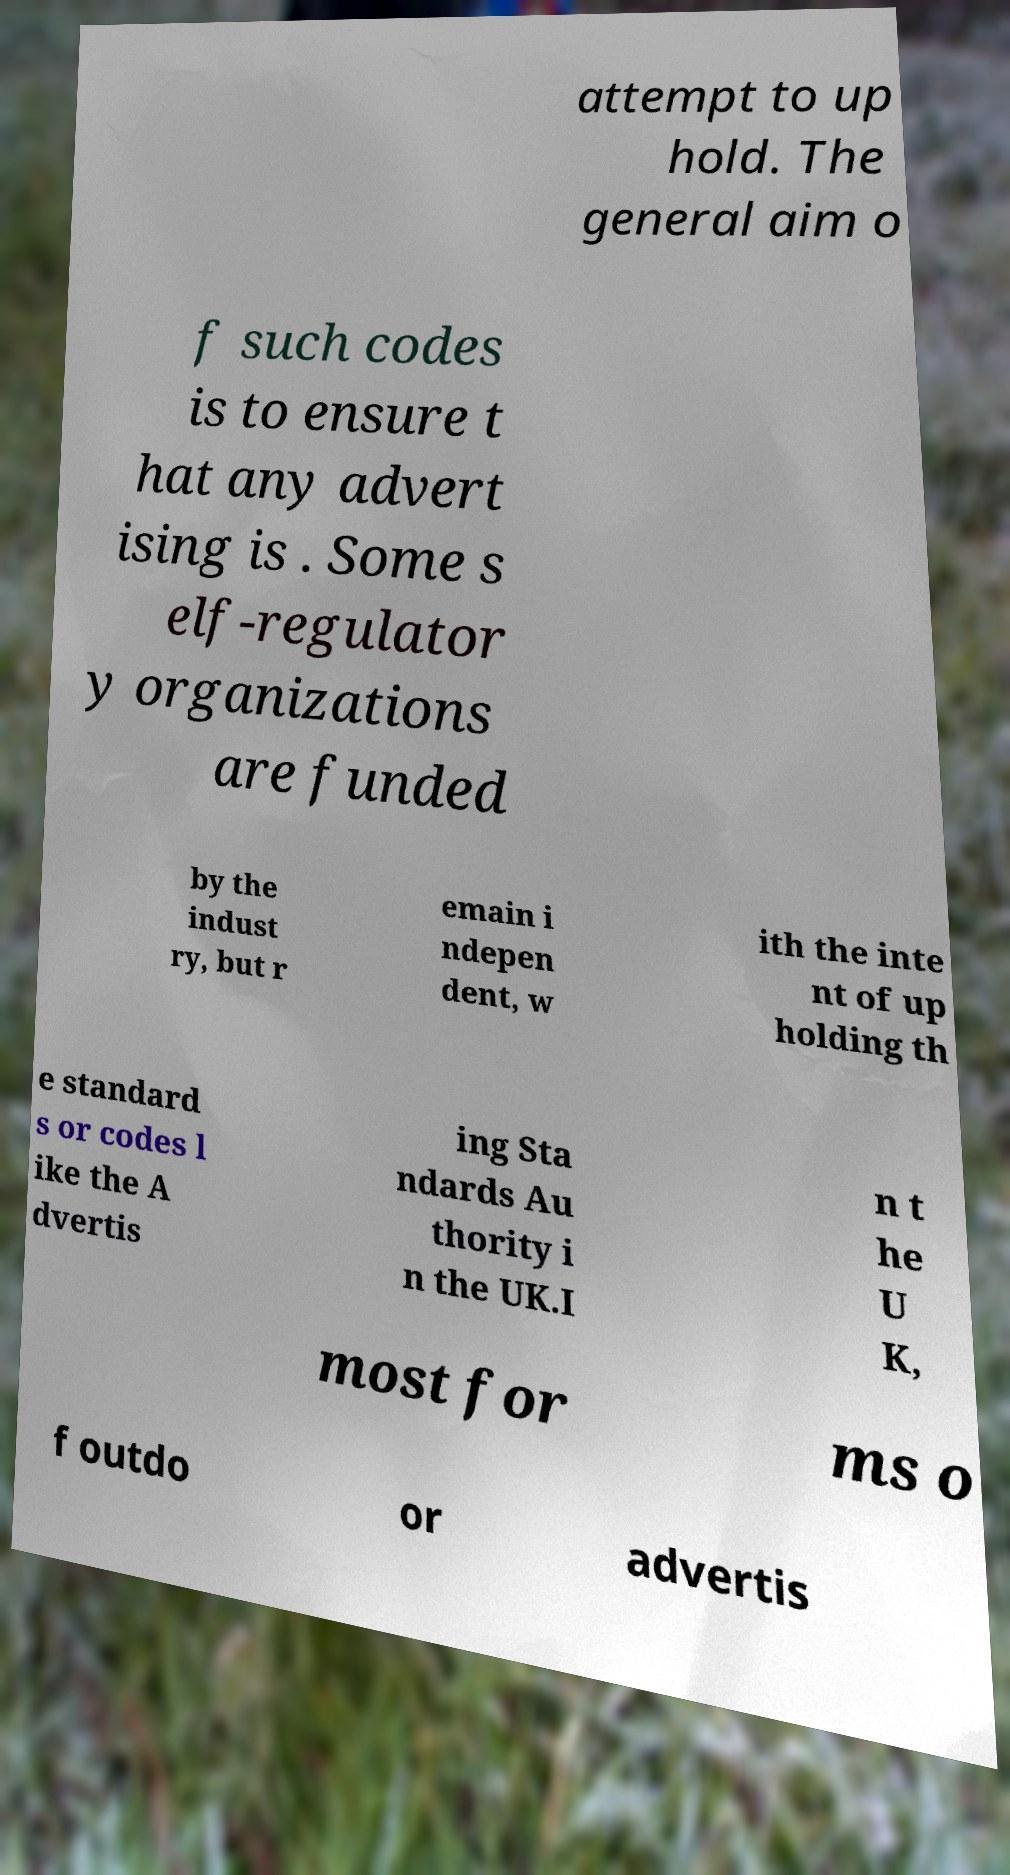Could you extract and type out the text from this image? attempt to up hold. The general aim o f such codes is to ensure t hat any advert ising is . Some s elf-regulator y organizations are funded by the indust ry, but r emain i ndepen dent, w ith the inte nt of up holding th e standard s or codes l ike the A dvertis ing Sta ndards Au thority i n the UK.I n t he U K, most for ms o f outdo or advertis 